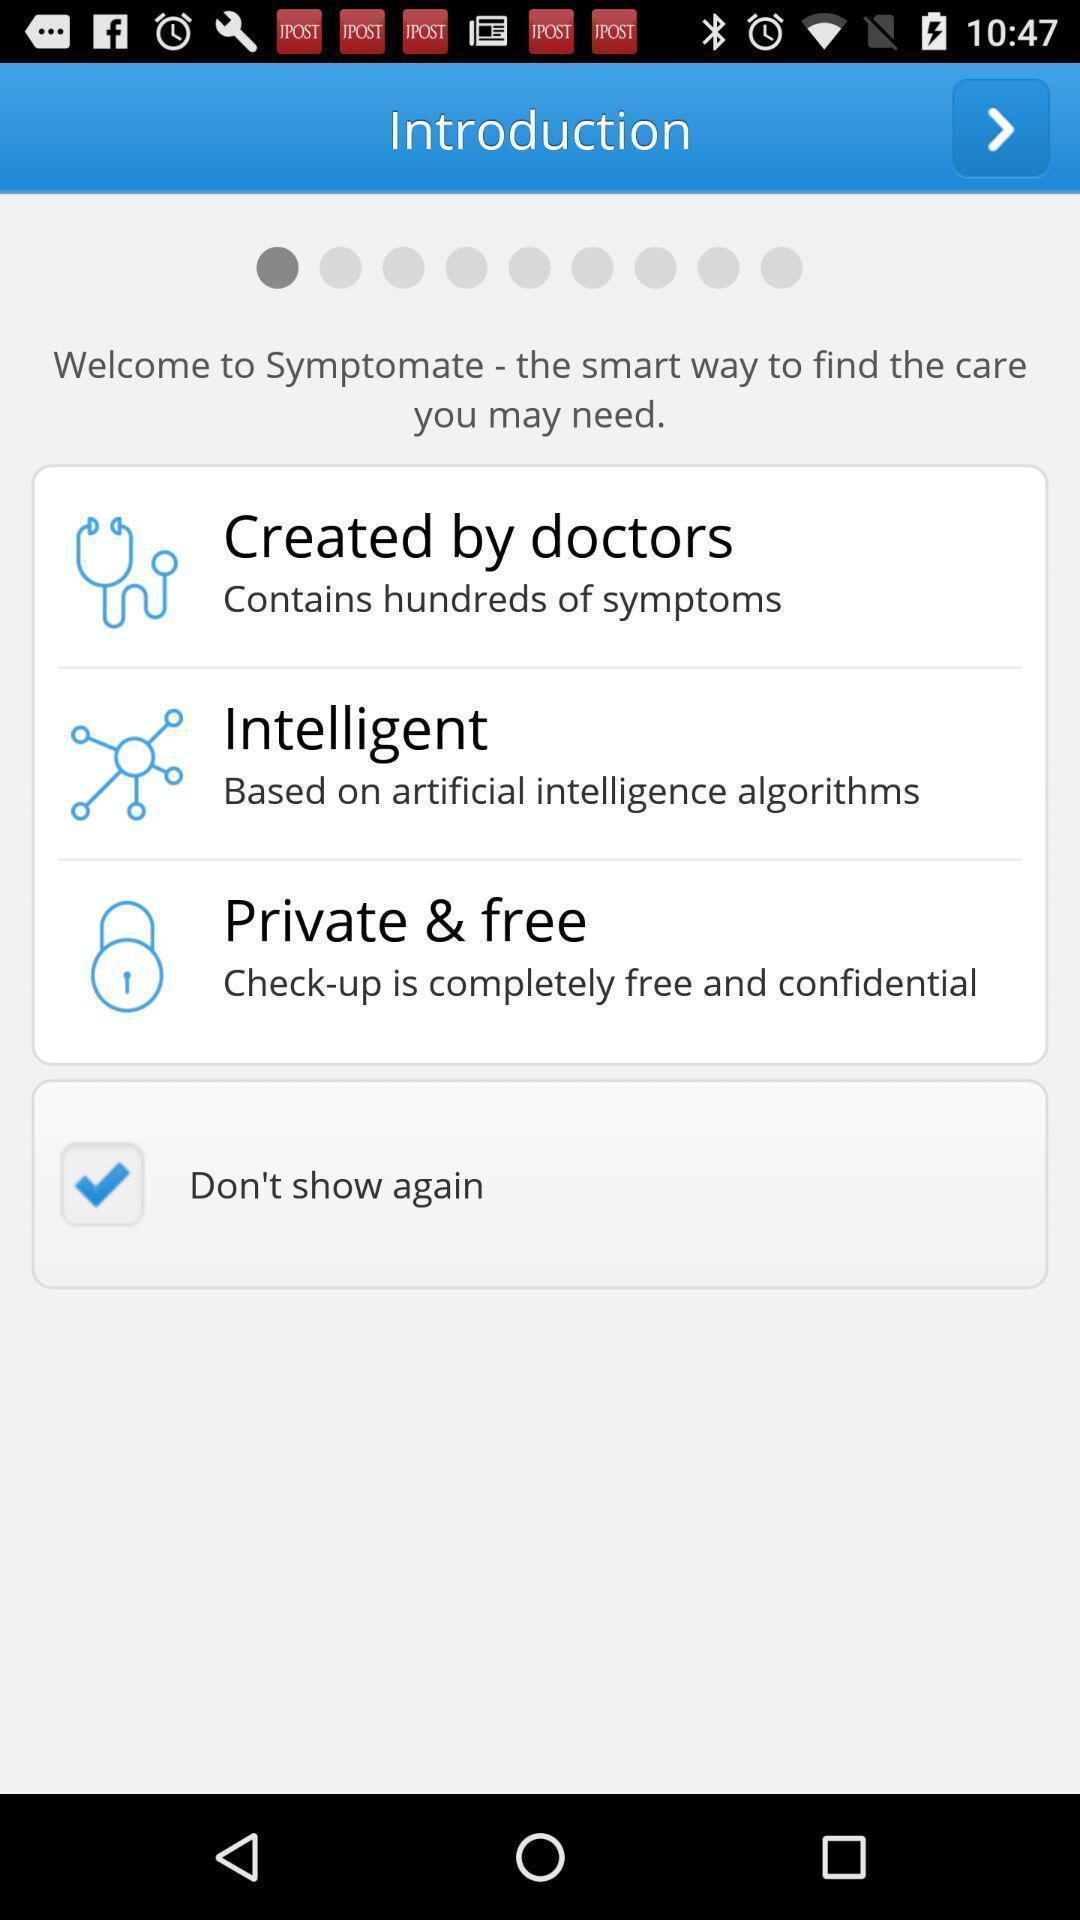Explain what's happening in this screen capture. Window displaying a medical app. 